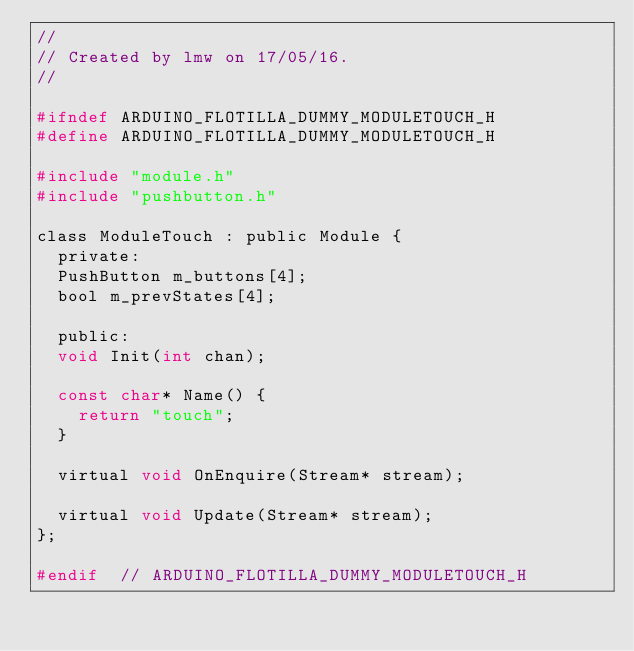<code> <loc_0><loc_0><loc_500><loc_500><_C_>//
// Created by lmw on 17/05/16.
//

#ifndef ARDUINO_FLOTILLA_DUMMY_MODULETOUCH_H
#define ARDUINO_FLOTILLA_DUMMY_MODULETOUCH_H

#include "module.h"
#include "pushbutton.h"

class ModuleTouch : public Module {
  private:
	PushButton m_buttons[4];
	bool m_prevStates[4];

  public:
	void Init(int chan);

	const char* Name() {
		return "touch";
	}

	virtual void OnEnquire(Stream* stream);

	virtual void Update(Stream* stream);
};

#endif  // ARDUINO_FLOTILLA_DUMMY_MODULETOUCH_H
</code> 